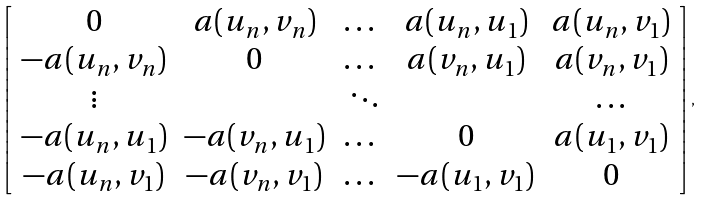<formula> <loc_0><loc_0><loc_500><loc_500>\left [ \begin{array} { c c c c c } 0 & a ( u _ { n } , v _ { n } ) & \dots & a ( u _ { n } , u _ { 1 } ) & a ( u _ { n } , v _ { 1 } ) \\ - a ( u _ { n } , v _ { n } ) & 0 & \dots & a ( v _ { n } , u _ { 1 } ) & a ( v _ { n } , v _ { 1 } ) \\ \vdots & & \ \ddots & & \dots \\ - a ( u _ { n } , u _ { 1 } ) & - a ( v _ { n } , u _ { 1 } ) & \dots & 0 & a ( u _ { 1 } , v _ { 1 } ) \\ - a ( u _ { n } , v _ { 1 } ) & - a ( v _ { n } , v _ { 1 } ) & \dots & - a ( u _ { 1 } , v _ { 1 } ) & 0 \\ \end{array} \right ] ,</formula> 